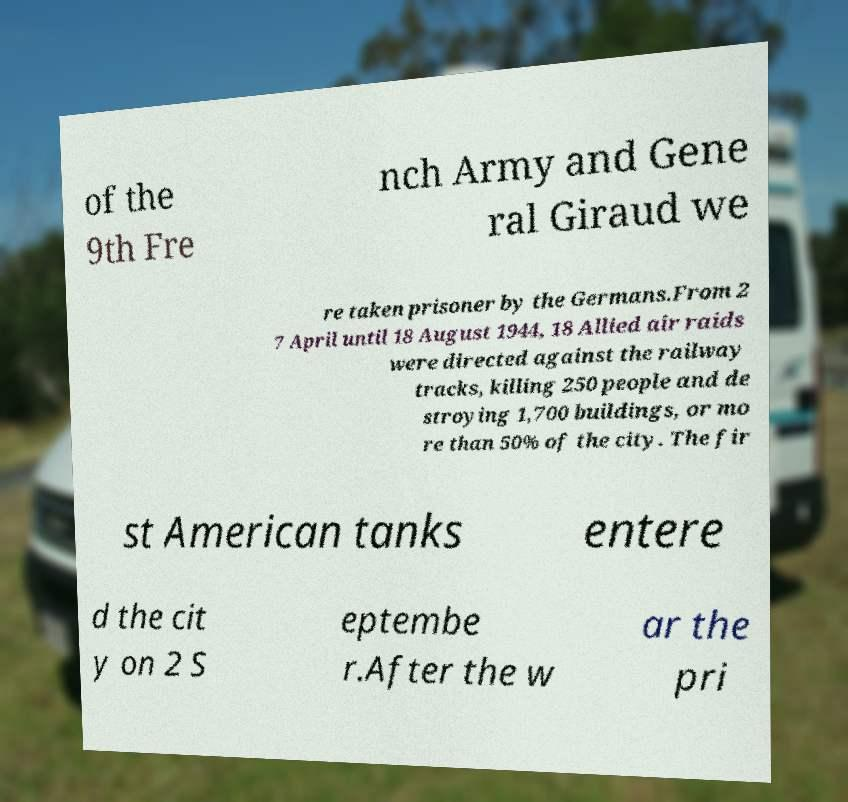Could you assist in decoding the text presented in this image and type it out clearly? of the 9th Fre nch Army and Gene ral Giraud we re taken prisoner by the Germans.From 2 7 April until 18 August 1944, 18 Allied air raids were directed against the railway tracks, killing 250 people and de stroying 1,700 buildings, or mo re than 50% of the city. The fir st American tanks entere d the cit y on 2 S eptembe r.After the w ar the pri 